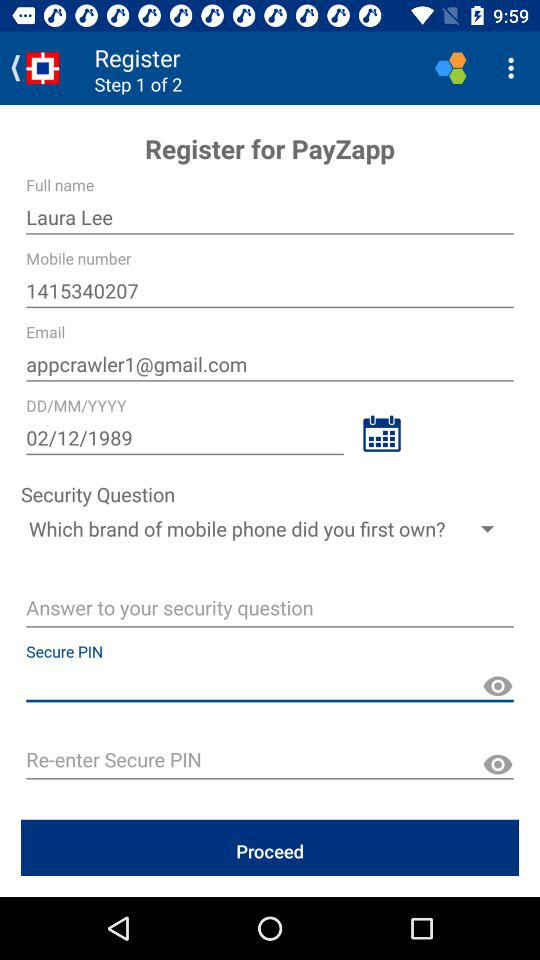Which step of registration am I on? You are on the first step. 